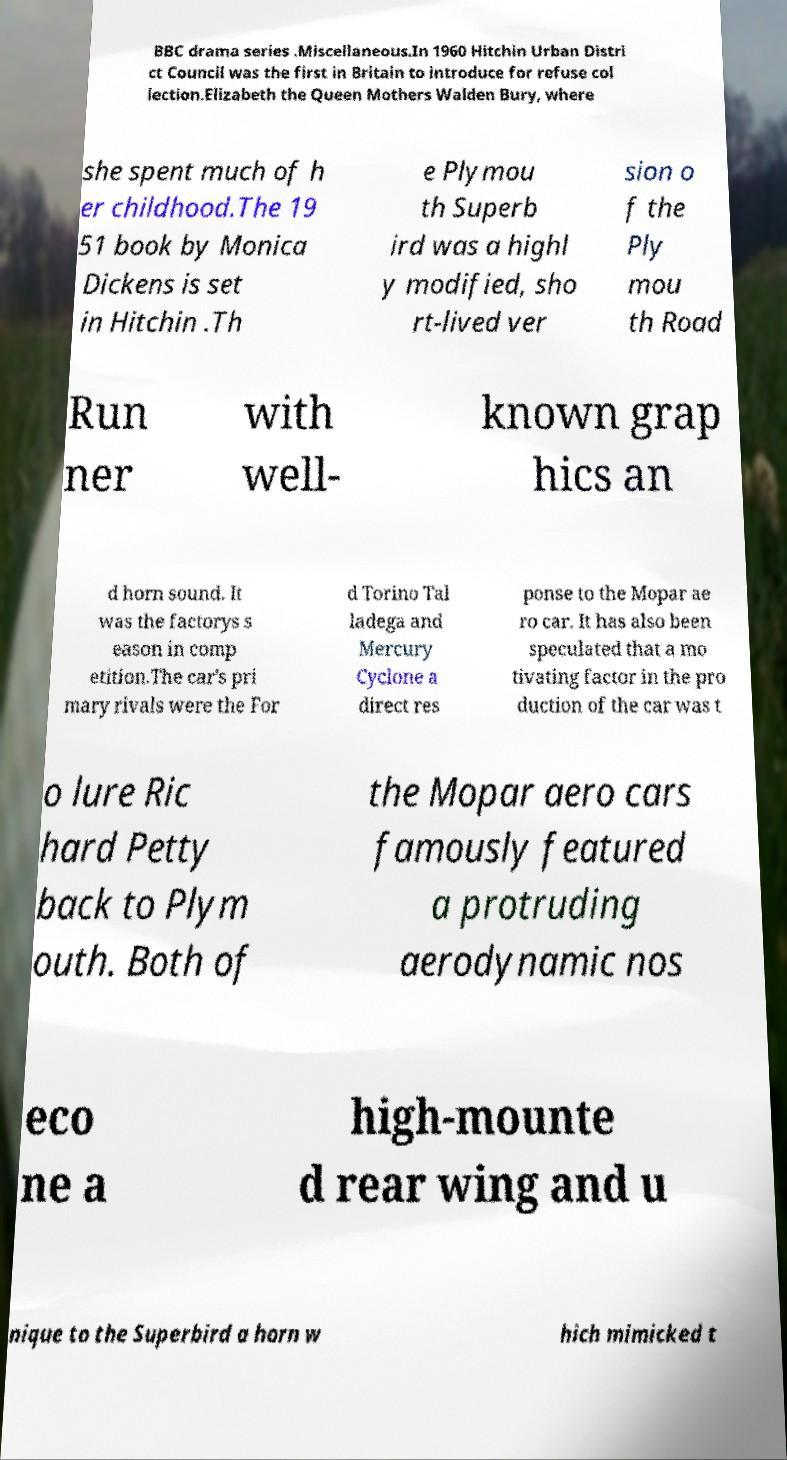I need the written content from this picture converted into text. Can you do that? BBC drama series .Miscellaneous.In 1960 Hitchin Urban Distri ct Council was the first in Britain to introduce for refuse col lection.Elizabeth the Queen Mothers Walden Bury, where she spent much of h er childhood.The 19 51 book by Monica Dickens is set in Hitchin .Th e Plymou th Superb ird was a highl y modified, sho rt-lived ver sion o f the Ply mou th Road Run ner with well- known grap hics an d horn sound. It was the factorys s eason in comp etition.The car's pri mary rivals were the For d Torino Tal ladega and Mercury Cyclone a direct res ponse to the Mopar ae ro car. It has also been speculated that a mo tivating factor in the pro duction of the car was t o lure Ric hard Petty back to Plym outh. Both of the Mopar aero cars famously featured a protruding aerodynamic nos eco ne a high-mounte d rear wing and u nique to the Superbird a horn w hich mimicked t 